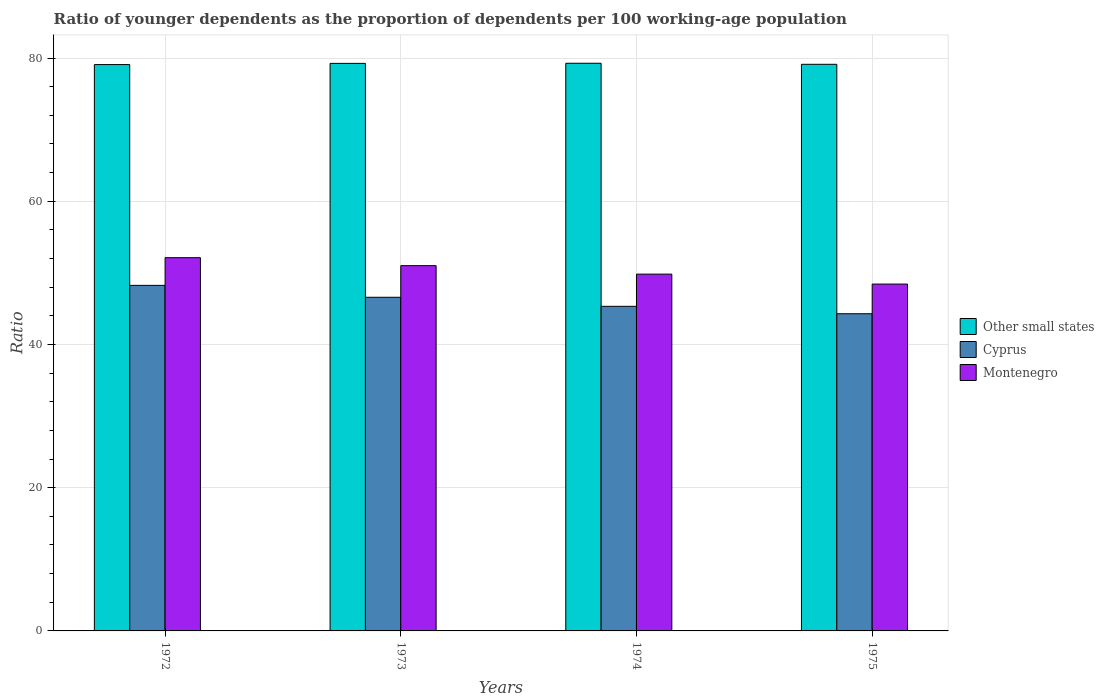How many bars are there on the 4th tick from the left?
Offer a terse response. 3. What is the label of the 4th group of bars from the left?
Provide a short and direct response. 1975. What is the age dependency ratio(young) in Montenegro in 1973?
Your answer should be compact. 51.01. Across all years, what is the maximum age dependency ratio(young) in Montenegro?
Your answer should be very brief. 52.12. Across all years, what is the minimum age dependency ratio(young) in Cyprus?
Your response must be concise. 44.29. In which year was the age dependency ratio(young) in Other small states maximum?
Offer a very short reply. 1974. In which year was the age dependency ratio(young) in Cyprus minimum?
Give a very brief answer. 1975. What is the total age dependency ratio(young) in Other small states in the graph?
Keep it short and to the point. 316.73. What is the difference between the age dependency ratio(young) in Montenegro in 1972 and that in 1975?
Offer a very short reply. 3.69. What is the difference between the age dependency ratio(young) in Cyprus in 1975 and the age dependency ratio(young) in Montenegro in 1972?
Provide a short and direct response. -7.83. What is the average age dependency ratio(young) in Cyprus per year?
Your response must be concise. 46.12. In the year 1974, what is the difference between the age dependency ratio(young) in Montenegro and age dependency ratio(young) in Cyprus?
Keep it short and to the point. 4.49. In how many years, is the age dependency ratio(young) in Montenegro greater than 8?
Provide a succinct answer. 4. What is the ratio of the age dependency ratio(young) in Other small states in 1972 to that in 1973?
Ensure brevity in your answer.  1. Is the age dependency ratio(young) in Montenegro in 1972 less than that in 1974?
Offer a very short reply. No. What is the difference between the highest and the second highest age dependency ratio(young) in Other small states?
Offer a very short reply. 0.02. What is the difference between the highest and the lowest age dependency ratio(young) in Cyprus?
Ensure brevity in your answer.  3.96. In how many years, is the age dependency ratio(young) in Other small states greater than the average age dependency ratio(young) in Other small states taken over all years?
Offer a very short reply. 2. Is the sum of the age dependency ratio(young) in Other small states in 1973 and 1974 greater than the maximum age dependency ratio(young) in Montenegro across all years?
Your response must be concise. Yes. What does the 3rd bar from the left in 1974 represents?
Your answer should be compact. Montenegro. What does the 3rd bar from the right in 1972 represents?
Ensure brevity in your answer.  Other small states. Is it the case that in every year, the sum of the age dependency ratio(young) in Montenegro and age dependency ratio(young) in Cyprus is greater than the age dependency ratio(young) in Other small states?
Give a very brief answer. Yes. How many bars are there?
Provide a short and direct response. 12. How many years are there in the graph?
Offer a terse response. 4. Does the graph contain grids?
Offer a very short reply. Yes. Where does the legend appear in the graph?
Your response must be concise. Center right. How many legend labels are there?
Offer a very short reply. 3. What is the title of the graph?
Offer a terse response. Ratio of younger dependents as the proportion of dependents per 100 working-age population. What is the label or title of the X-axis?
Ensure brevity in your answer.  Years. What is the label or title of the Y-axis?
Your response must be concise. Ratio. What is the Ratio of Other small states in 1972?
Your answer should be very brief. 79.08. What is the Ratio of Cyprus in 1972?
Offer a terse response. 48.26. What is the Ratio of Montenegro in 1972?
Your response must be concise. 52.12. What is the Ratio of Other small states in 1973?
Your answer should be compact. 79.25. What is the Ratio of Cyprus in 1973?
Ensure brevity in your answer.  46.59. What is the Ratio in Montenegro in 1973?
Offer a very short reply. 51.01. What is the Ratio in Other small states in 1974?
Offer a very short reply. 79.27. What is the Ratio in Cyprus in 1974?
Provide a succinct answer. 45.33. What is the Ratio in Montenegro in 1974?
Give a very brief answer. 49.82. What is the Ratio of Other small states in 1975?
Offer a terse response. 79.12. What is the Ratio of Cyprus in 1975?
Make the answer very short. 44.29. What is the Ratio of Montenegro in 1975?
Ensure brevity in your answer.  48.44. Across all years, what is the maximum Ratio in Other small states?
Provide a short and direct response. 79.27. Across all years, what is the maximum Ratio in Cyprus?
Offer a very short reply. 48.26. Across all years, what is the maximum Ratio of Montenegro?
Offer a very short reply. 52.12. Across all years, what is the minimum Ratio in Other small states?
Your response must be concise. 79.08. Across all years, what is the minimum Ratio of Cyprus?
Your response must be concise. 44.29. Across all years, what is the minimum Ratio of Montenegro?
Your answer should be compact. 48.44. What is the total Ratio in Other small states in the graph?
Offer a very short reply. 316.73. What is the total Ratio in Cyprus in the graph?
Your answer should be compact. 184.47. What is the total Ratio of Montenegro in the graph?
Give a very brief answer. 201.39. What is the difference between the Ratio in Other small states in 1972 and that in 1973?
Your answer should be very brief. -0.17. What is the difference between the Ratio of Cyprus in 1972 and that in 1973?
Keep it short and to the point. 1.66. What is the difference between the Ratio of Montenegro in 1972 and that in 1973?
Your response must be concise. 1.11. What is the difference between the Ratio of Other small states in 1972 and that in 1974?
Your answer should be very brief. -0.19. What is the difference between the Ratio in Cyprus in 1972 and that in 1974?
Provide a short and direct response. 2.93. What is the difference between the Ratio of Montenegro in 1972 and that in 1974?
Offer a terse response. 2.3. What is the difference between the Ratio in Other small states in 1972 and that in 1975?
Give a very brief answer. -0.04. What is the difference between the Ratio of Cyprus in 1972 and that in 1975?
Ensure brevity in your answer.  3.96. What is the difference between the Ratio in Montenegro in 1972 and that in 1975?
Provide a short and direct response. 3.69. What is the difference between the Ratio in Other small states in 1973 and that in 1974?
Provide a succinct answer. -0.02. What is the difference between the Ratio of Cyprus in 1973 and that in 1974?
Give a very brief answer. 1.26. What is the difference between the Ratio of Montenegro in 1973 and that in 1974?
Your answer should be very brief. 1.18. What is the difference between the Ratio in Other small states in 1973 and that in 1975?
Your answer should be compact. 0.13. What is the difference between the Ratio in Cyprus in 1973 and that in 1975?
Give a very brief answer. 2.3. What is the difference between the Ratio of Montenegro in 1973 and that in 1975?
Make the answer very short. 2.57. What is the difference between the Ratio of Other small states in 1974 and that in 1975?
Make the answer very short. 0.15. What is the difference between the Ratio in Cyprus in 1974 and that in 1975?
Your response must be concise. 1.04. What is the difference between the Ratio in Montenegro in 1974 and that in 1975?
Your answer should be compact. 1.39. What is the difference between the Ratio of Other small states in 1972 and the Ratio of Cyprus in 1973?
Ensure brevity in your answer.  32.49. What is the difference between the Ratio of Other small states in 1972 and the Ratio of Montenegro in 1973?
Provide a short and direct response. 28.08. What is the difference between the Ratio of Cyprus in 1972 and the Ratio of Montenegro in 1973?
Your answer should be compact. -2.75. What is the difference between the Ratio of Other small states in 1972 and the Ratio of Cyprus in 1974?
Keep it short and to the point. 33.76. What is the difference between the Ratio of Other small states in 1972 and the Ratio of Montenegro in 1974?
Make the answer very short. 29.26. What is the difference between the Ratio in Cyprus in 1972 and the Ratio in Montenegro in 1974?
Keep it short and to the point. -1.57. What is the difference between the Ratio in Other small states in 1972 and the Ratio in Cyprus in 1975?
Keep it short and to the point. 34.79. What is the difference between the Ratio of Other small states in 1972 and the Ratio of Montenegro in 1975?
Your answer should be compact. 30.65. What is the difference between the Ratio of Cyprus in 1972 and the Ratio of Montenegro in 1975?
Give a very brief answer. -0.18. What is the difference between the Ratio of Other small states in 1973 and the Ratio of Cyprus in 1974?
Keep it short and to the point. 33.93. What is the difference between the Ratio of Other small states in 1973 and the Ratio of Montenegro in 1974?
Offer a terse response. 29.43. What is the difference between the Ratio of Cyprus in 1973 and the Ratio of Montenegro in 1974?
Offer a very short reply. -3.23. What is the difference between the Ratio in Other small states in 1973 and the Ratio in Cyprus in 1975?
Offer a terse response. 34.96. What is the difference between the Ratio of Other small states in 1973 and the Ratio of Montenegro in 1975?
Make the answer very short. 30.82. What is the difference between the Ratio in Cyprus in 1973 and the Ratio in Montenegro in 1975?
Your response must be concise. -1.84. What is the difference between the Ratio of Other small states in 1974 and the Ratio of Cyprus in 1975?
Your answer should be very brief. 34.98. What is the difference between the Ratio in Other small states in 1974 and the Ratio in Montenegro in 1975?
Your response must be concise. 30.84. What is the difference between the Ratio of Cyprus in 1974 and the Ratio of Montenegro in 1975?
Make the answer very short. -3.11. What is the average Ratio in Other small states per year?
Your response must be concise. 79.18. What is the average Ratio of Cyprus per year?
Provide a succinct answer. 46.12. What is the average Ratio in Montenegro per year?
Keep it short and to the point. 50.35. In the year 1972, what is the difference between the Ratio of Other small states and Ratio of Cyprus?
Offer a very short reply. 30.83. In the year 1972, what is the difference between the Ratio of Other small states and Ratio of Montenegro?
Your response must be concise. 26.96. In the year 1972, what is the difference between the Ratio in Cyprus and Ratio in Montenegro?
Provide a short and direct response. -3.87. In the year 1973, what is the difference between the Ratio in Other small states and Ratio in Cyprus?
Give a very brief answer. 32.66. In the year 1973, what is the difference between the Ratio of Other small states and Ratio of Montenegro?
Your answer should be compact. 28.25. In the year 1973, what is the difference between the Ratio of Cyprus and Ratio of Montenegro?
Give a very brief answer. -4.41. In the year 1974, what is the difference between the Ratio of Other small states and Ratio of Cyprus?
Your response must be concise. 33.94. In the year 1974, what is the difference between the Ratio in Other small states and Ratio in Montenegro?
Your answer should be compact. 29.45. In the year 1974, what is the difference between the Ratio of Cyprus and Ratio of Montenegro?
Make the answer very short. -4.49. In the year 1975, what is the difference between the Ratio of Other small states and Ratio of Cyprus?
Provide a succinct answer. 34.83. In the year 1975, what is the difference between the Ratio in Other small states and Ratio in Montenegro?
Ensure brevity in your answer.  30.69. In the year 1975, what is the difference between the Ratio in Cyprus and Ratio in Montenegro?
Keep it short and to the point. -4.14. What is the ratio of the Ratio in Cyprus in 1972 to that in 1973?
Provide a succinct answer. 1.04. What is the ratio of the Ratio in Montenegro in 1972 to that in 1973?
Make the answer very short. 1.02. What is the ratio of the Ratio in Cyprus in 1972 to that in 1974?
Offer a terse response. 1.06. What is the ratio of the Ratio of Montenegro in 1972 to that in 1974?
Keep it short and to the point. 1.05. What is the ratio of the Ratio of Cyprus in 1972 to that in 1975?
Offer a very short reply. 1.09. What is the ratio of the Ratio of Montenegro in 1972 to that in 1975?
Provide a succinct answer. 1.08. What is the ratio of the Ratio in Cyprus in 1973 to that in 1974?
Offer a very short reply. 1.03. What is the ratio of the Ratio in Montenegro in 1973 to that in 1974?
Keep it short and to the point. 1.02. What is the ratio of the Ratio of Cyprus in 1973 to that in 1975?
Ensure brevity in your answer.  1.05. What is the ratio of the Ratio in Montenegro in 1973 to that in 1975?
Your answer should be compact. 1.05. What is the ratio of the Ratio of Cyprus in 1974 to that in 1975?
Ensure brevity in your answer.  1.02. What is the ratio of the Ratio in Montenegro in 1974 to that in 1975?
Provide a short and direct response. 1.03. What is the difference between the highest and the second highest Ratio in Other small states?
Your response must be concise. 0.02. What is the difference between the highest and the second highest Ratio in Cyprus?
Give a very brief answer. 1.66. What is the difference between the highest and the second highest Ratio of Montenegro?
Ensure brevity in your answer.  1.11. What is the difference between the highest and the lowest Ratio in Other small states?
Offer a terse response. 0.19. What is the difference between the highest and the lowest Ratio of Cyprus?
Provide a succinct answer. 3.96. What is the difference between the highest and the lowest Ratio of Montenegro?
Provide a short and direct response. 3.69. 